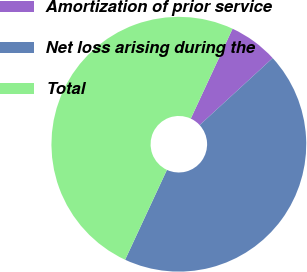<chart> <loc_0><loc_0><loc_500><loc_500><pie_chart><fcel>Amortization of prior service<fcel>Net loss arising during the<fcel>Total<nl><fcel>6.25%<fcel>43.75%<fcel>50.0%<nl></chart> 